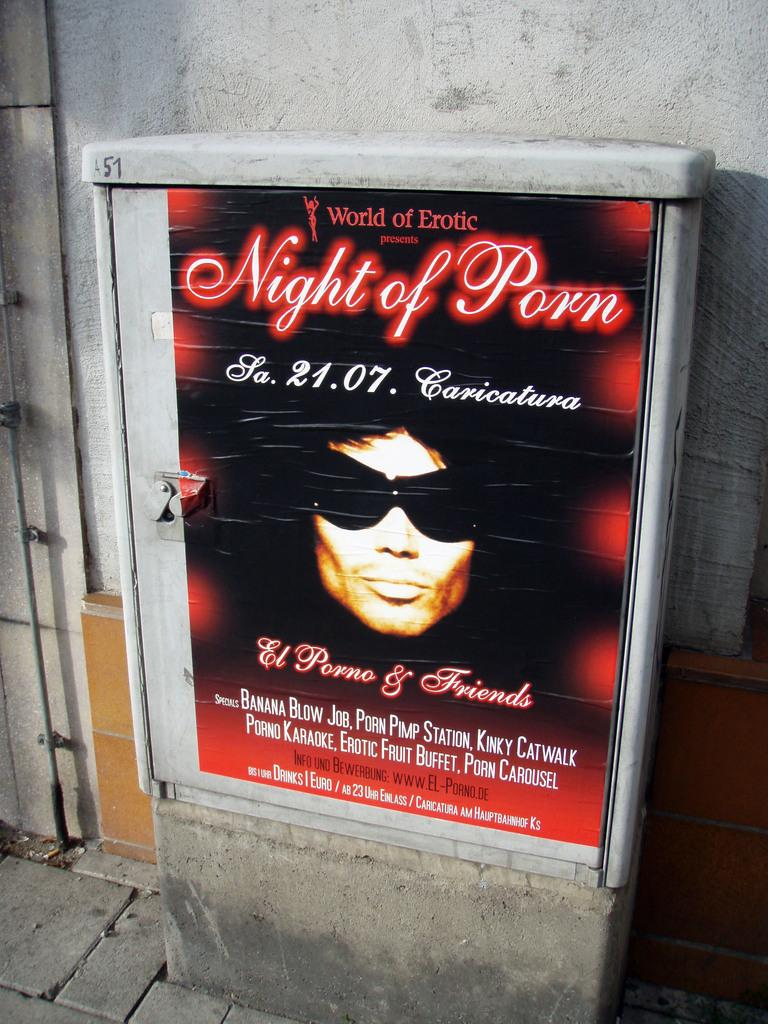<image>
Write a terse but informative summary of the picture. The word night of the porn is written on a red, black and white poster. 